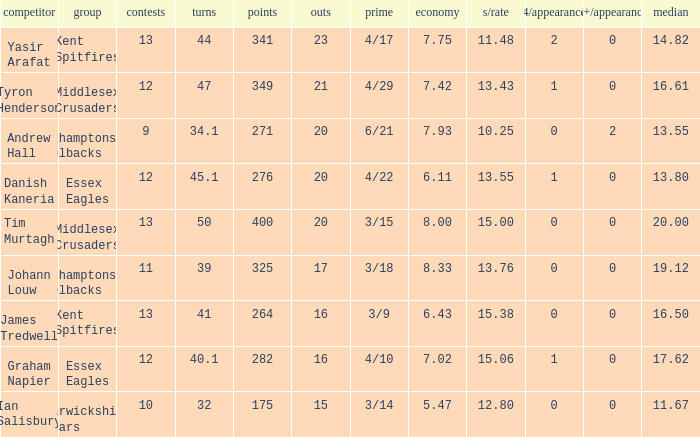Name the most 4/inns 2.0. Could you help me parse every detail presented in this table? {'header': ['competitor', 'group', 'contests', 'turns', 'points', 'outs', 'prime', 'economy', 's/rate', '4/appearance', '5+/appearance', 'median'], 'rows': [['Yasir Arafat', 'Kent Spitfires', '13', '44', '341', '23', '4/17', '7.75', '11.48', '2', '0', '14.82'], ['Tyron Henderson', 'Middlesex Crusaders', '12', '47', '349', '21', '4/29', '7.42', '13.43', '1', '0', '16.61'], ['Andrew Hall', 'Northamptonshire Steelbacks', '9', '34.1', '271', '20', '6/21', '7.93', '10.25', '0', '2', '13.55'], ['Danish Kaneria', 'Essex Eagles', '12', '45.1', '276', '20', '4/22', '6.11', '13.55', '1', '0', '13.80'], ['Tim Murtagh', 'Middlesex Crusaders', '13', '50', '400', '20', '3/15', '8.00', '15.00', '0', '0', '20.00'], ['Johann Louw', 'Northamptonshire Steelbacks', '11', '39', '325', '17', '3/18', '8.33', '13.76', '0', '0', '19.12'], ['James Tredwell', 'Kent Spitfires', '13', '41', '264', '16', '3/9', '6.43', '15.38', '0', '0', '16.50'], ['Graham Napier', 'Essex Eagles', '12', '40.1', '282', '16', '4/10', '7.02', '15.06', '1', '0', '17.62'], ['Ian Salisbury', 'Warwickshire Bears', '10', '32', '175', '15', '3/14', '5.47', '12.80', '0', '0', '11.67']]} 